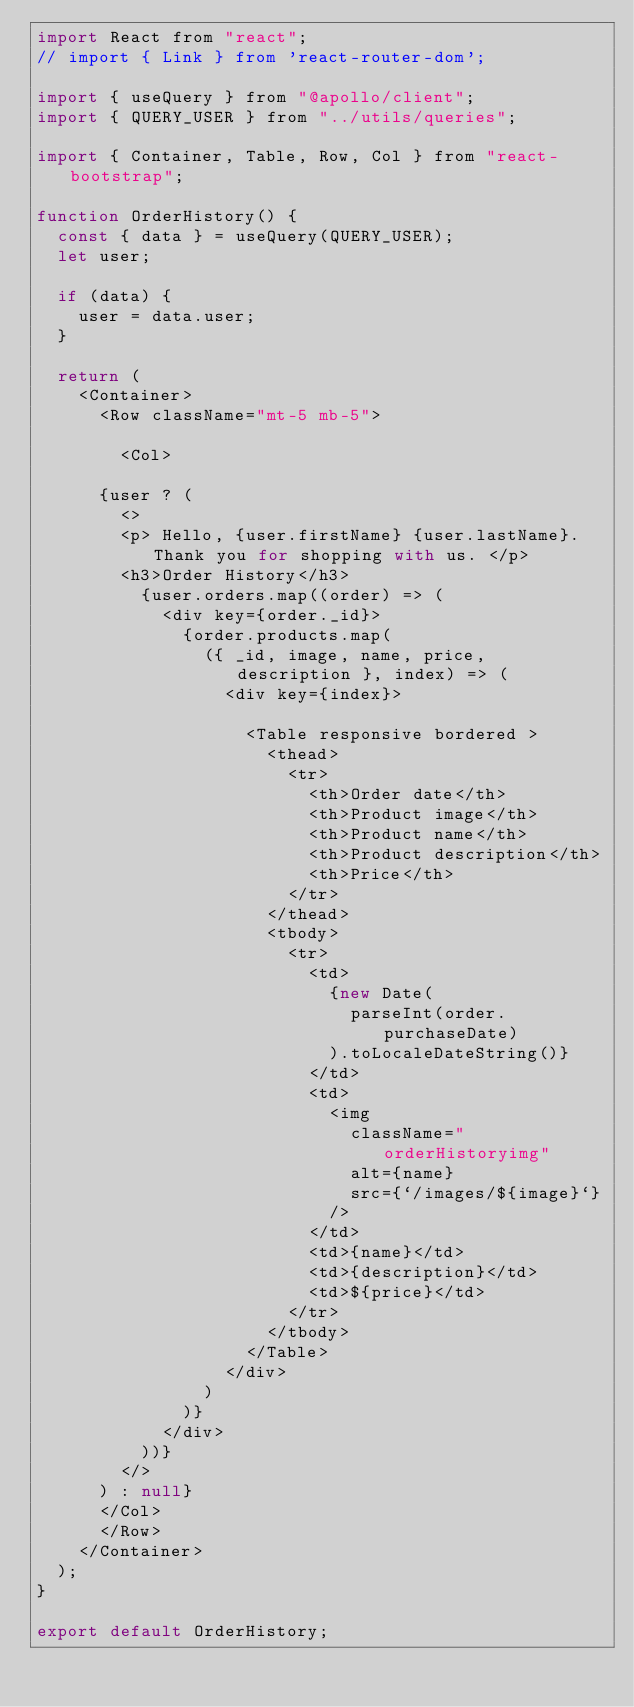Convert code to text. <code><loc_0><loc_0><loc_500><loc_500><_JavaScript_>import React from "react";
// import { Link } from 'react-router-dom';

import { useQuery } from "@apollo/client";
import { QUERY_USER } from "../utils/queries";

import { Container, Table, Row, Col } from "react-bootstrap";

function OrderHistory() {
  const { data } = useQuery(QUERY_USER);
  let user;

  if (data) {
    user = data.user;
  }

  return (
    <Container>
      <Row className="mt-5 mb-5">
        
        <Col>
        
      {user ? (
        <>
        <p> Hello, {user.firstName} {user.lastName}. Thank you for shopping with us. </p> 
        <h3>Order History</h3>
          {user.orders.map((order) => (
            <div key={order._id}>
              {order.products.map(
                ({ _id, image, name, price, description }, index) => (
                  <div key={index}>
                    
                    <Table responsive bordered >
                      <thead>
                        <tr>
                          <th>Order date</th>
                          <th>Product image</th>
                          <th>Product name</th>
                          <th>Product description</th>
                          <th>Price</th>
                        </tr>
                      </thead>
                      <tbody>
                        <tr>
                          <td>
                            {new Date(
                              parseInt(order.purchaseDate)
                            ).toLocaleDateString()}
                          </td>
                          <td>
                            <img
                              className="orderHistoryimg"
                              alt={name}
                              src={`/images/${image}`}
                            />
                          </td>
                          <td>{name}</td>
                          <td>{description}</td>
                          <td>${price}</td>
                        </tr>
                      </tbody>
                    </Table>
                  </div>
                )
              )}
            </div>
          ))}
        </>
      ) : null}
      </Col>
      </Row>
    </Container>
  );
}

export default OrderHistory;
</code> 